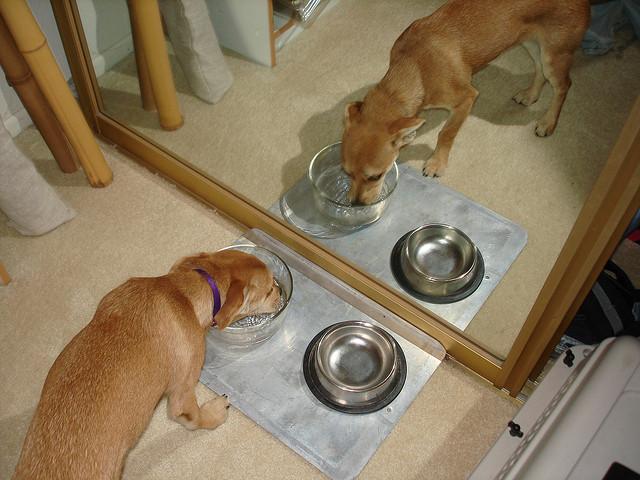What is the dog in front of?
Give a very brief answer. Mirror. Are there two animals?
Quick response, please. No. What is the dog doing?
Give a very brief answer. Drinking. 